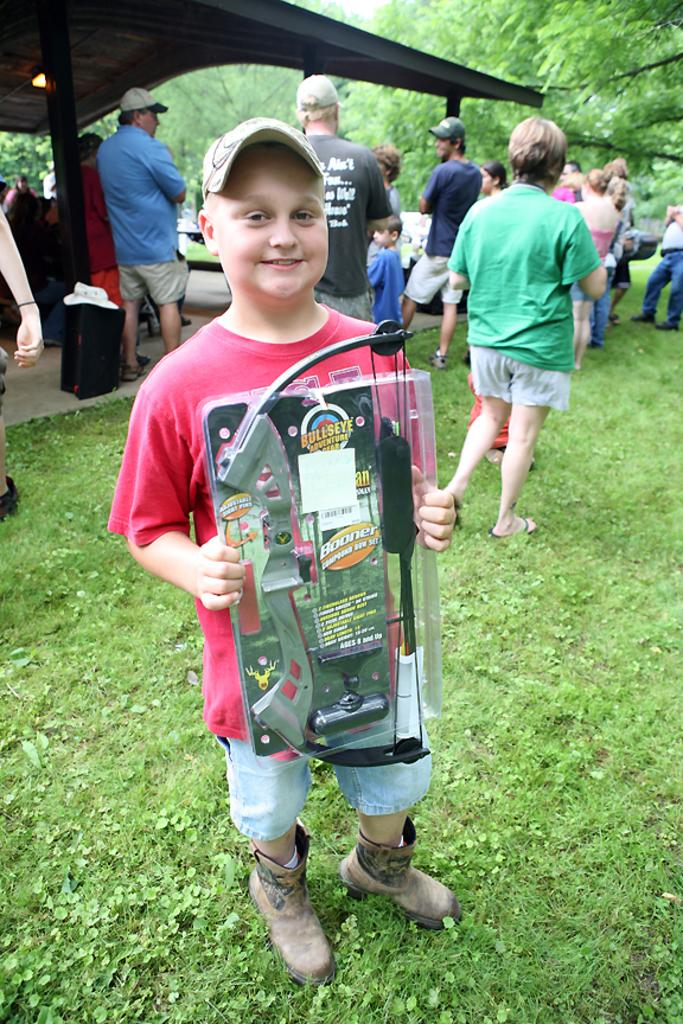What is the primary feature of the land in the image? The land is covered with grass. What is the boy holding in the image? The boy is holding a toy. What can be seen in the background of the image? There is an open-shed, pillars, people, and trees in the background. What type of brass instrument is being played by the people in the background? There is no brass instrument or any indication of music being played in the image. 